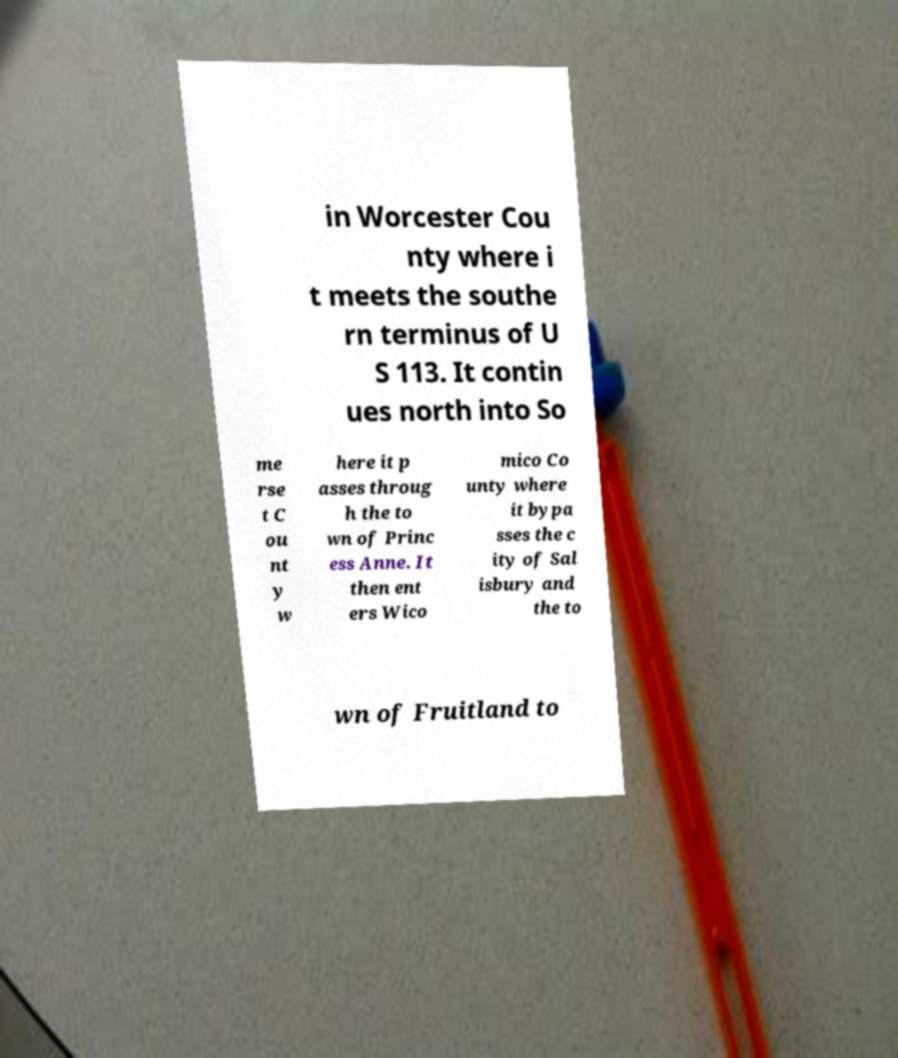There's text embedded in this image that I need extracted. Can you transcribe it verbatim? in Worcester Cou nty where i t meets the southe rn terminus of U S 113. It contin ues north into So me rse t C ou nt y w here it p asses throug h the to wn of Princ ess Anne. It then ent ers Wico mico Co unty where it bypa sses the c ity of Sal isbury and the to wn of Fruitland to 